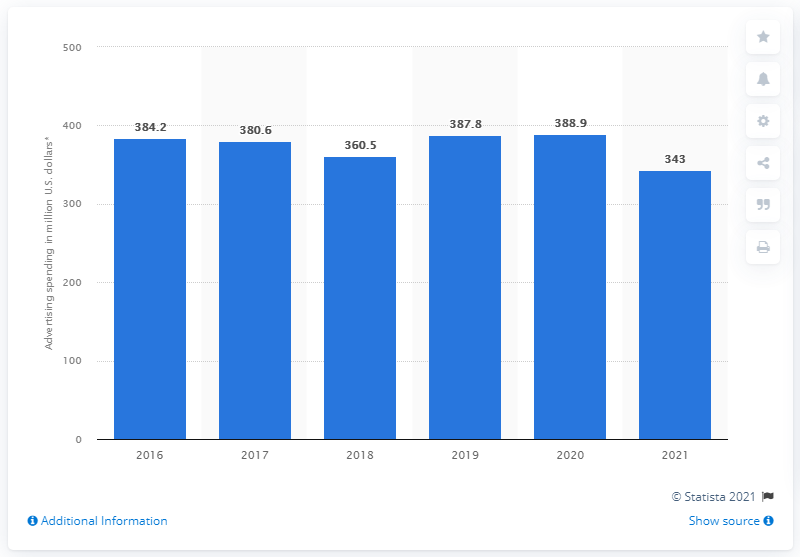Specify some key components in this picture. Signet Jewelers spent approximately $343 million on advertising in 2021. 